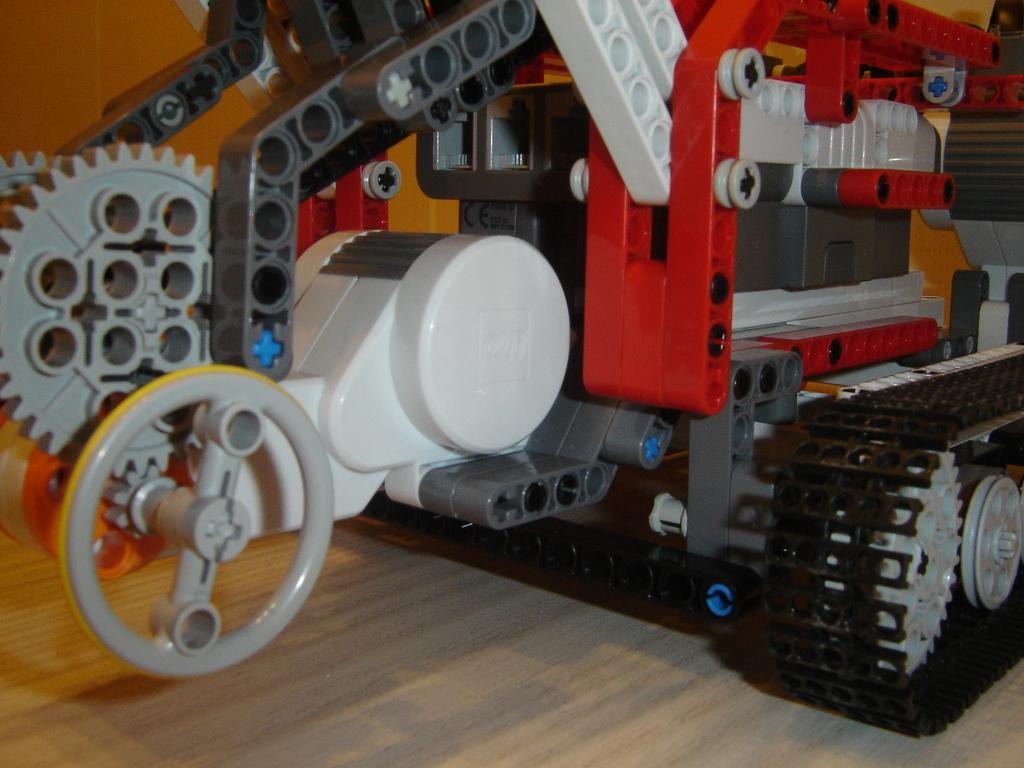What type of object is the main subject in the image? There is a toy vehicle in the image. Can you describe the colors of the toy vehicle? The toy vehicle is red, white, and black in color. What type of seed is being planted in the image? There is no seed or planting activity present in the image; it features a toy vehicle. Can you describe the smile on the toy vehicle's face? The toy vehicle does not have a face or a smile, as it is an inanimate object. 